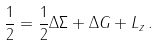Convert formula to latex. <formula><loc_0><loc_0><loc_500><loc_500>\frac { 1 } { 2 } = \frac { 1 } { 2 } \Delta \Sigma + \Delta G + L _ { z } \, .</formula> 